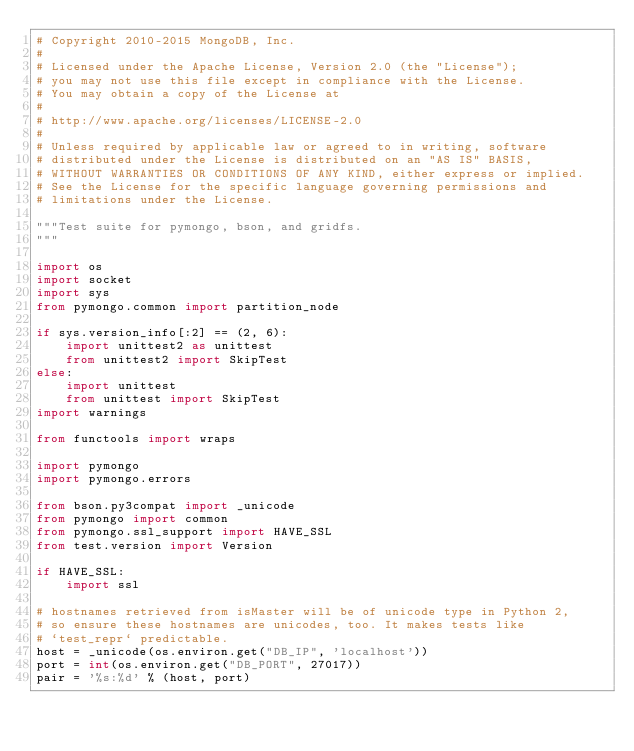<code> <loc_0><loc_0><loc_500><loc_500><_Python_># Copyright 2010-2015 MongoDB, Inc.
#
# Licensed under the Apache License, Version 2.0 (the "License");
# you may not use this file except in compliance with the License.
# You may obtain a copy of the License at
#
# http://www.apache.org/licenses/LICENSE-2.0
#
# Unless required by applicable law or agreed to in writing, software
# distributed under the License is distributed on an "AS IS" BASIS,
# WITHOUT WARRANTIES OR CONDITIONS OF ANY KIND, either express or implied.
# See the License for the specific language governing permissions and
# limitations under the License.

"""Test suite for pymongo, bson, and gridfs.
"""

import os
import socket
import sys
from pymongo.common import partition_node

if sys.version_info[:2] == (2, 6):
    import unittest2 as unittest
    from unittest2 import SkipTest
else:
    import unittest
    from unittest import SkipTest
import warnings

from functools import wraps

import pymongo
import pymongo.errors

from bson.py3compat import _unicode
from pymongo import common
from pymongo.ssl_support import HAVE_SSL
from test.version import Version

if HAVE_SSL:
    import ssl

# hostnames retrieved from isMaster will be of unicode type in Python 2,
# so ensure these hostnames are unicodes, too. It makes tests like
# `test_repr` predictable.
host = _unicode(os.environ.get("DB_IP", 'localhost'))
port = int(os.environ.get("DB_PORT", 27017))
pair = '%s:%d' % (host, port)
</code> 